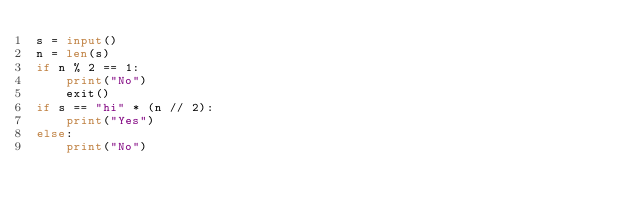<code> <loc_0><loc_0><loc_500><loc_500><_Python_>s = input()
n = len(s)
if n % 2 == 1:
    print("No")
    exit()
if s == "hi" * (n // 2):
    print("Yes")
else:
    print("No")</code> 